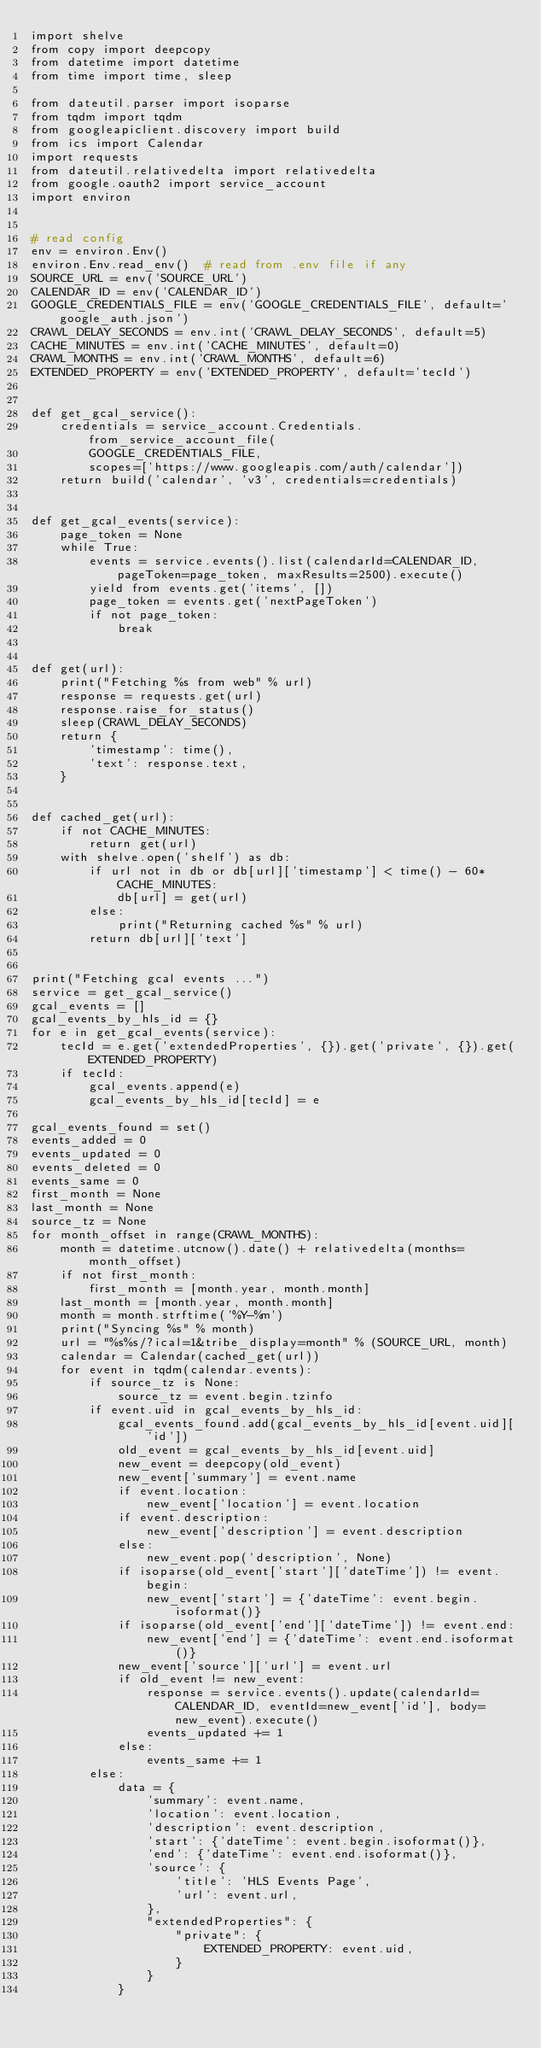Convert code to text. <code><loc_0><loc_0><loc_500><loc_500><_Python_>import shelve
from copy import deepcopy
from datetime import datetime
from time import time, sleep

from dateutil.parser import isoparse
from tqdm import tqdm
from googleapiclient.discovery import build
from ics import Calendar
import requests
from dateutil.relativedelta import relativedelta
from google.oauth2 import service_account
import environ


# read config
env = environ.Env()
environ.Env.read_env()  # read from .env file if any
SOURCE_URL = env('SOURCE_URL')
CALENDAR_ID = env('CALENDAR_ID')
GOOGLE_CREDENTIALS_FILE = env('GOOGLE_CREDENTIALS_FILE', default='google_auth.json')
CRAWL_DELAY_SECONDS = env.int('CRAWL_DELAY_SECONDS', default=5)
CACHE_MINUTES = env.int('CACHE_MINUTES', default=0)
CRAWL_MONTHS = env.int('CRAWL_MONTHS', default=6)
EXTENDED_PROPERTY = env('EXTENDED_PROPERTY', default='tecId')


def get_gcal_service():
    credentials = service_account.Credentials.from_service_account_file(
        GOOGLE_CREDENTIALS_FILE,
        scopes=['https://www.googleapis.com/auth/calendar'])
    return build('calendar', 'v3', credentials=credentials)


def get_gcal_events(service):
    page_token = None
    while True:
        events = service.events().list(calendarId=CALENDAR_ID, pageToken=page_token, maxResults=2500).execute()
        yield from events.get('items', [])
        page_token = events.get('nextPageToken')
        if not page_token:
            break


def get(url):
    print("Fetching %s from web" % url)
    response = requests.get(url)
    response.raise_for_status()
    sleep(CRAWL_DELAY_SECONDS)
    return {
        'timestamp': time(),
        'text': response.text,
    }


def cached_get(url):
    if not CACHE_MINUTES:
        return get(url)
    with shelve.open('shelf') as db:
        if url not in db or db[url]['timestamp'] < time() - 60*CACHE_MINUTES:
            db[url] = get(url)
        else:
            print("Returning cached %s" % url)
        return db[url]['text']


print("Fetching gcal events ...")
service = get_gcal_service()
gcal_events = []
gcal_events_by_hls_id = {}
for e in get_gcal_events(service):
    tecId = e.get('extendedProperties', {}).get('private', {}).get(EXTENDED_PROPERTY)
    if tecId:
        gcal_events.append(e)
        gcal_events_by_hls_id[tecId] = e

gcal_events_found = set()
events_added = 0
events_updated = 0
events_deleted = 0
events_same = 0
first_month = None
last_month = None
source_tz = None
for month_offset in range(CRAWL_MONTHS):
    month = datetime.utcnow().date() + relativedelta(months=month_offset)
    if not first_month:
        first_month = [month.year, month.month]
    last_month = [month.year, month.month]
    month = month.strftime('%Y-%m')
    print("Syncing %s" % month)
    url = "%s%s/?ical=1&tribe_display=month" % (SOURCE_URL, month)
    calendar = Calendar(cached_get(url))
    for event in tqdm(calendar.events):
        if source_tz is None:
            source_tz = event.begin.tzinfo
        if event.uid in gcal_events_by_hls_id:
            gcal_events_found.add(gcal_events_by_hls_id[event.uid]['id'])
            old_event = gcal_events_by_hls_id[event.uid]
            new_event = deepcopy(old_event)
            new_event['summary'] = event.name
            if event.location:
                new_event['location'] = event.location
            if event.description:
                new_event['description'] = event.description
            else:
                new_event.pop('description', None)
            if isoparse(old_event['start']['dateTime']) != event.begin:
                new_event['start'] = {'dateTime': event.begin.isoformat()}
            if isoparse(old_event['end']['dateTime']) != event.end:
                new_event['end'] = {'dateTime': event.end.isoformat()}
            new_event['source']['url'] = event.url
            if old_event != new_event:
                response = service.events().update(calendarId=CALENDAR_ID, eventId=new_event['id'], body=new_event).execute()
                events_updated += 1
            else:
                events_same += 1
        else:
            data = {
                'summary': event.name,
                'location': event.location,
                'description': event.description,
                'start': {'dateTime': event.begin.isoformat()},
                'end': {'dateTime': event.end.isoformat()},
                'source': {
                    'title': 'HLS Events Page',
                    'url': event.url,
                },
                "extendedProperties": {
                    "private": {
                        EXTENDED_PROPERTY: event.uid,
                    }
                }
            }</code> 